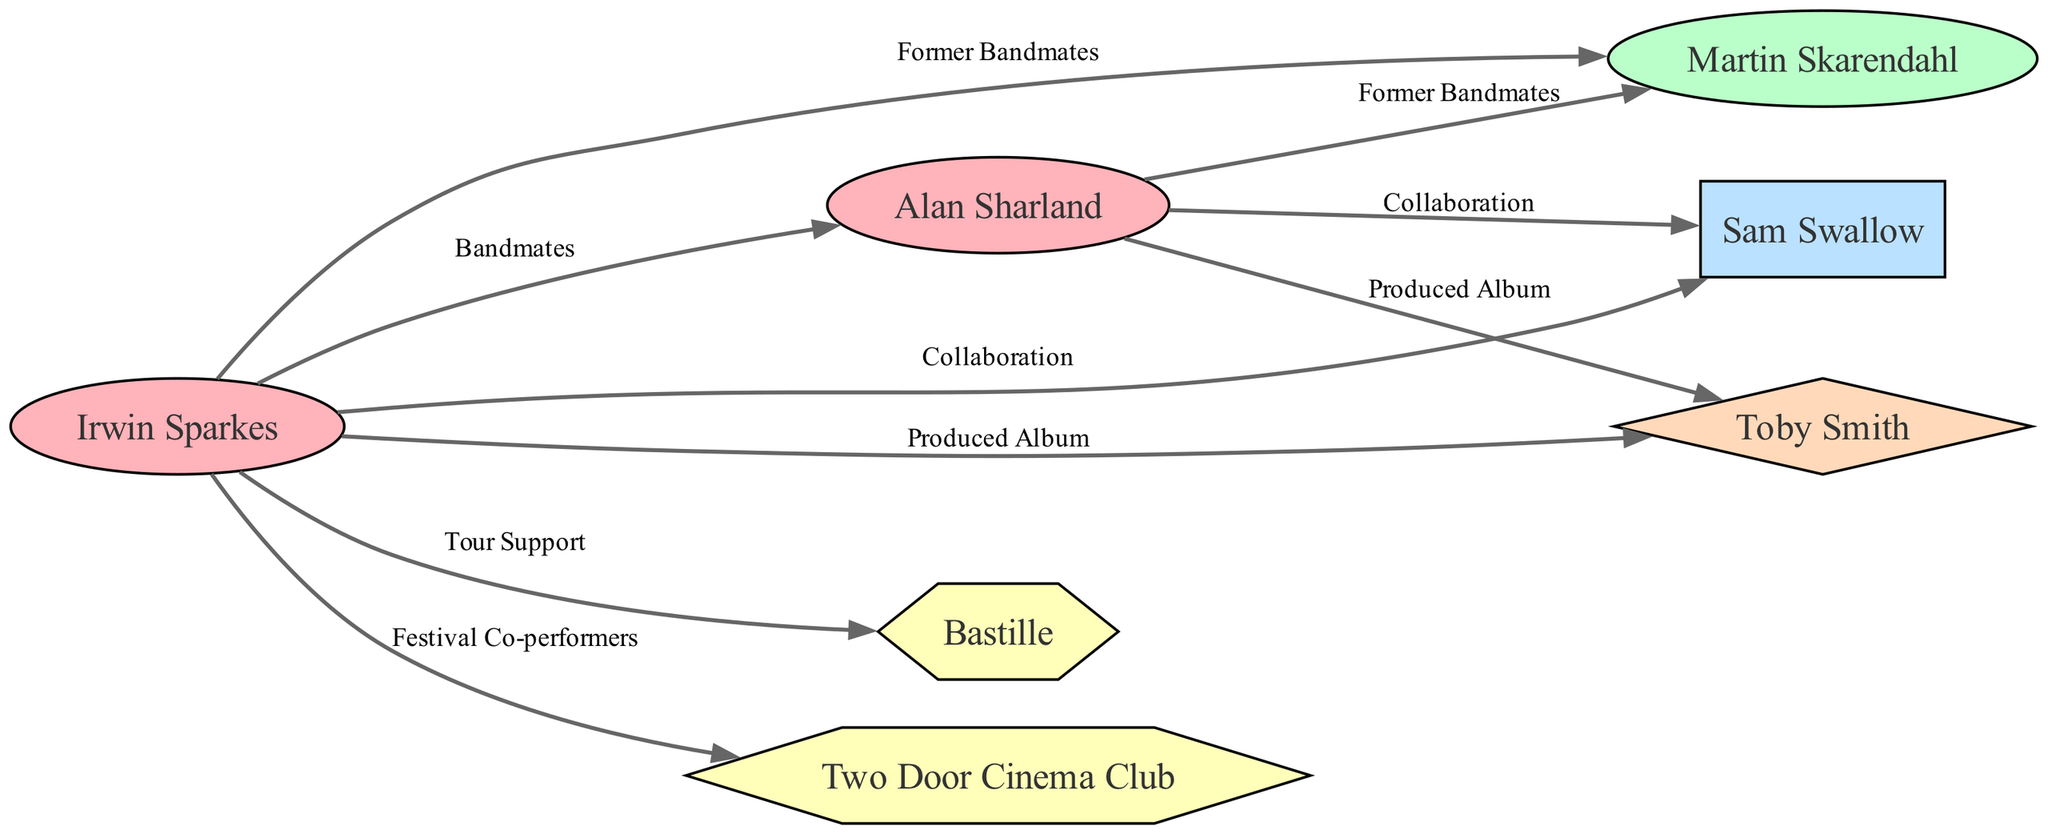What is the total number of nodes in the diagram? The diagram includes various entities such as band members, collaborators, indie pop artists, and a producer. By counting each unique entity in the 'nodes' section of the data, we find there are 7 nodes total.
Answer: 7 How many edges connect Irwin Sparkes to other nodes? Irwin Sparkes is connected to other nodes through edges that represent relationships. By examining the edges where Irwin Sparkes is either the source or target, we determine he has connections to 5 other nodes.
Answer: 5 What type of relationship connects Alan Sharland and Martin Skarendahl? To find the relationship type between Alan Sharland and Martin Skarendahl, we look for an edge in the data that connects these two nodes. In the edges section, there is an edge labeled "Former Bandmates" indicating their relationship.
Answer: Former Bandmates Who produced an album for The Hoosiers? The diagram shows that both Irwin Sparkes and Alan Sharland have edges that lead to Toby Smith, labeled "Produced Album." This indicates that Toby Smith is the person who produced albums for them.
Answer: Toby Smith Which indie pop artist did Irwin Sparkes have a tour support relationship with? We need to check the edges connecting Irwin Sparkes to any indie pop artists in the diagram. The edge labeled "Tour Support" connects him to "Bastille," indicating this relationship.
Answer: Bastille Which band member collaborated with Sam Swallow? To find this, we look at the edges that include Sam Swallow as a target. Both Irwin Sparkes and Alan Sharland are connected to Sam Swallow through the edges labeled "Collaboration."
Answer: Irwin Sparkes and Alan Sharland What is the relationship between Two Door Cinema Club and Irwin Sparkes? We can identify connections by reviewing the edges. There is a labeled edge "Festival Co-performers" between Irwin Sparkes and Two Door Cinema Club, indicating that they share this relationship.
Answer: Festival Co-performers How many former band members are represented in the diagram? To answer this, we look at the node types in the diagram. There is one node specifically labeled as "Former Band Member," which is Martin Skarendahl. Thus, the total is 1 former band member.
Answer: 1 